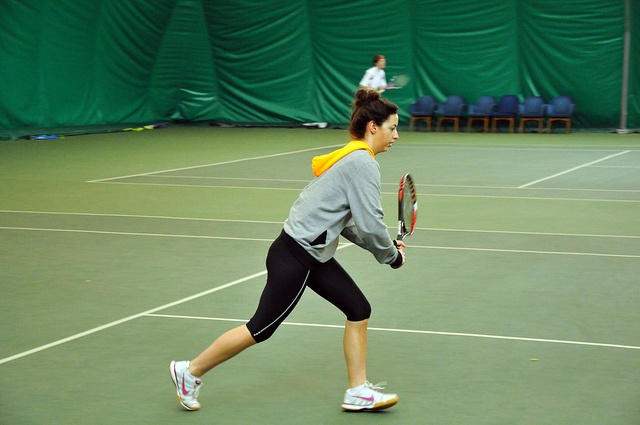Describe the objects in this image and their specific colors. I can see people in black, darkgray, tan, and lightgray tones, tennis racket in black, olive, and gray tones, people in black, lightgray, tan, darkgray, and lightblue tones, chair in black, blue, navy, and maroon tones, and chair in black, navy, maroon, and darkgreen tones in this image. 